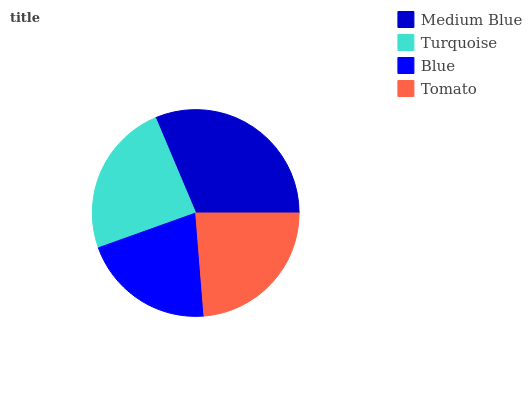Is Blue the minimum?
Answer yes or no. Yes. Is Medium Blue the maximum?
Answer yes or no. Yes. Is Turquoise the minimum?
Answer yes or no. No. Is Turquoise the maximum?
Answer yes or no. No. Is Medium Blue greater than Turquoise?
Answer yes or no. Yes. Is Turquoise less than Medium Blue?
Answer yes or no. Yes. Is Turquoise greater than Medium Blue?
Answer yes or no. No. Is Medium Blue less than Turquoise?
Answer yes or no. No. Is Turquoise the high median?
Answer yes or no. Yes. Is Tomato the low median?
Answer yes or no. Yes. Is Medium Blue the high median?
Answer yes or no. No. Is Medium Blue the low median?
Answer yes or no. No. 